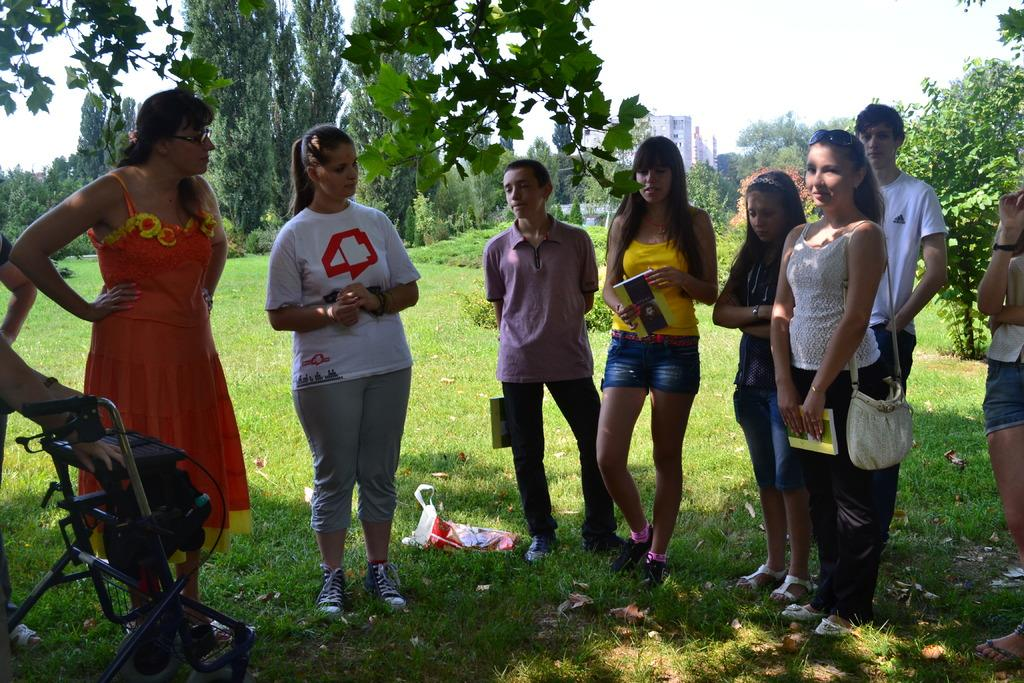Who is present in the image? There are girls in the image. Where are the girls located? The girls are standing in a garden. What are the girls holding in their hands? The girls are holding books in their hands. What can be seen in the background of the image? There are trees and buildings visible in the background of the image. What type of bird is perched on the veil of one of the girls in the image? There is no bird or veil present in the image; the girls are holding books and standing in a garden. 